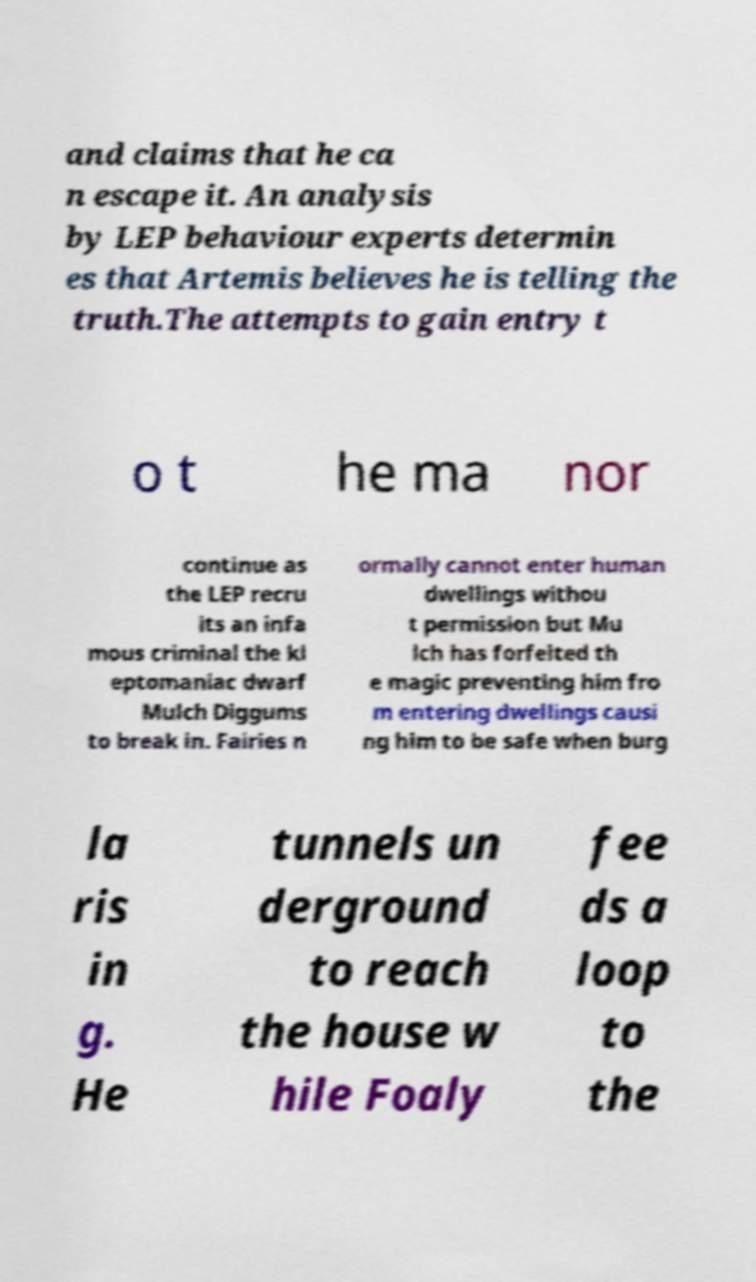There's text embedded in this image that I need extracted. Can you transcribe it verbatim? and claims that he ca n escape it. An analysis by LEP behaviour experts determin es that Artemis believes he is telling the truth.The attempts to gain entry t o t he ma nor continue as the LEP recru its an infa mous criminal the kl eptomaniac dwarf Mulch Diggums to break in. Fairies n ormally cannot enter human dwellings withou t permission but Mu lch has forfeited th e magic preventing him fro m entering dwellings causi ng him to be safe when burg la ris in g. He tunnels un derground to reach the house w hile Foaly fee ds a loop to the 